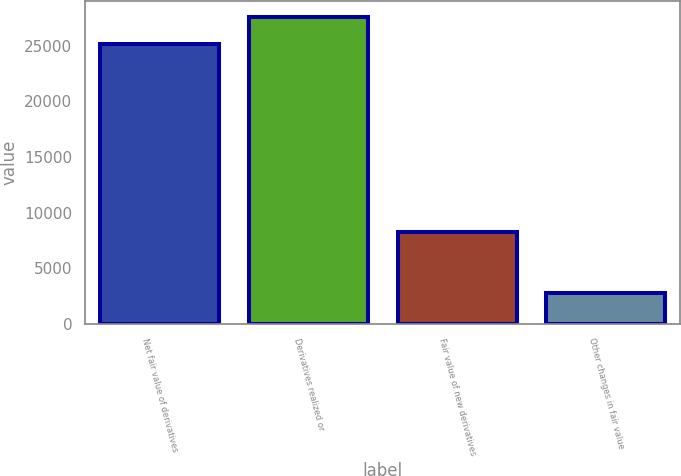<chart> <loc_0><loc_0><loc_500><loc_500><bar_chart><fcel>Net fair value of derivatives<fcel>Derivatives realized or<fcel>Fair value of new derivatives<fcel>Other changes in fair value<nl><fcel>25171<fcel>27619.5<fcel>8287<fcel>2766<nl></chart> 